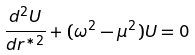Convert formula to latex. <formula><loc_0><loc_0><loc_500><loc_500>\frac { d ^ { 2 } U } { d r ^ { * 2 } } + ( \omega ^ { 2 } - \mu ^ { 2 } ) U = 0</formula> 